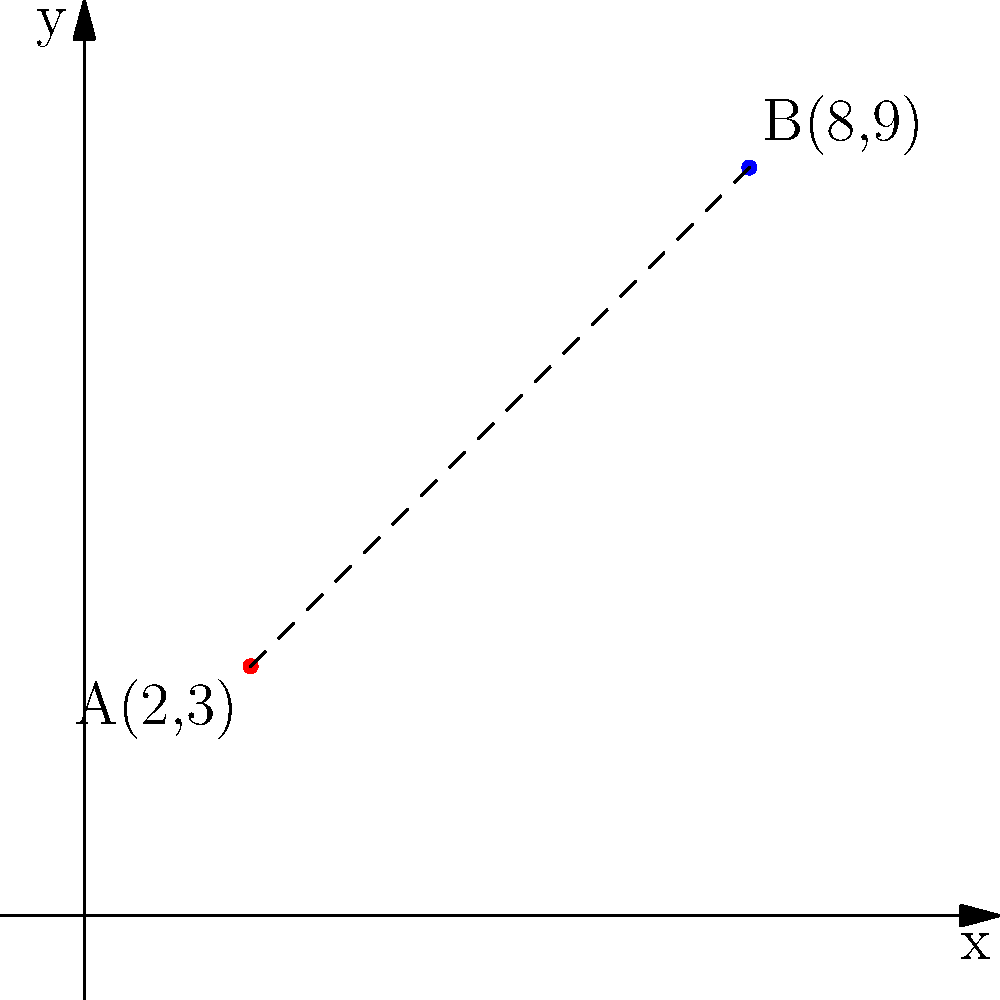As a project manager overseeing the production of technical manuals, you need to ensure accurate representations of distances in diagrams. Given two points on a coordinate plane: A(2,3) and B(8,9), calculate the distance between these points. Round your answer to two decimal places. To calculate the distance between two points on a coordinate plane, we use the distance formula:

$$ d = \sqrt{(x_2 - x_1)^2 + (y_2 - y_1)^2} $$

Where $(x_1, y_1)$ are the coordinates of the first point and $(x_2, y_2)$ are the coordinates of the second point.

Step 1: Identify the coordinates
Point A: $(x_1, y_1) = (2, 3)$
Point B: $(x_2, y_2) = (8, 9)$

Step 2: Plug the values into the distance formula
$$ d = \sqrt{(8 - 2)^2 + (9 - 3)^2} $$

Step 3: Simplify the expressions inside the parentheses
$$ d = \sqrt{6^2 + 6^2} $$

Step 4: Calculate the squares
$$ d = \sqrt{36 + 36} $$

Step 5: Add the values under the square root
$$ d = \sqrt{72} $$

Step 6: Simplify the square root
$$ d = 6\sqrt{2} $$

Step 7: Use a calculator to get the decimal approximation and round to two decimal places
$$ d \approx 8.49 $$
Answer: 8.49 units 